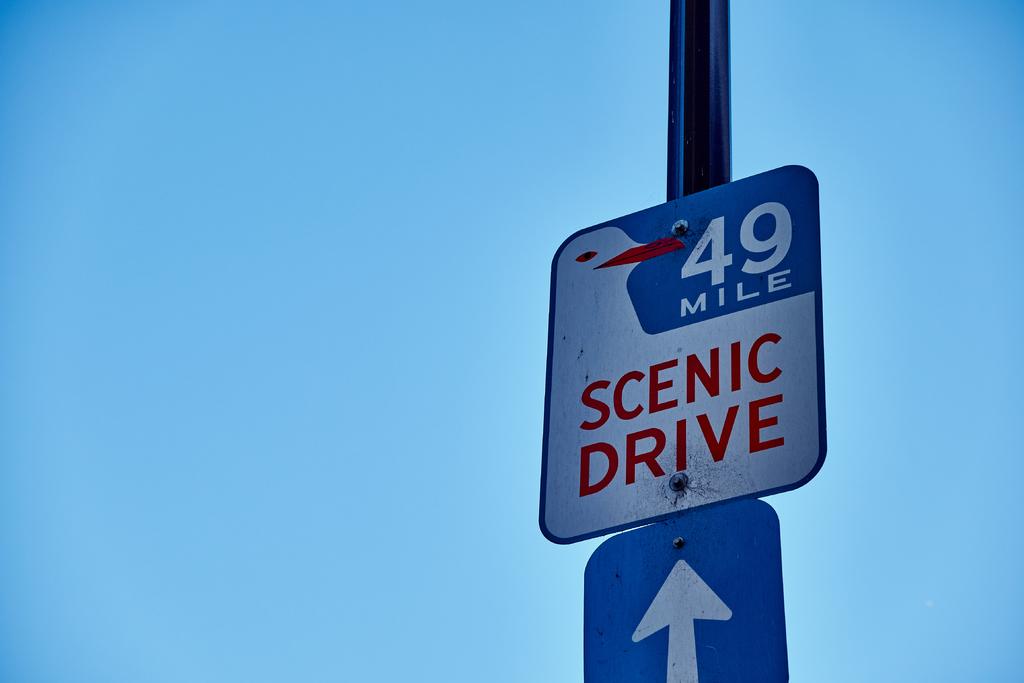How many miles are on this sign?
Offer a terse response. 49. What type of drive is ahead?
Keep it short and to the point. Scenic. 